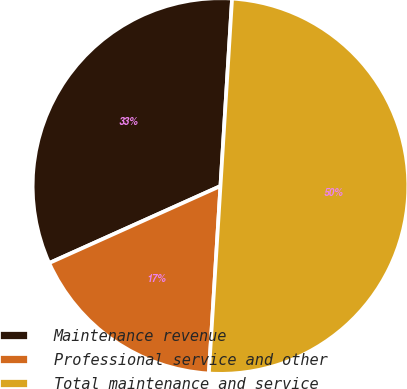Convert chart to OTSL. <chart><loc_0><loc_0><loc_500><loc_500><pie_chart><fcel>Maintenance revenue<fcel>Professional service and other<fcel>Total maintenance and service<nl><fcel>32.71%<fcel>17.29%<fcel>50.0%<nl></chart> 